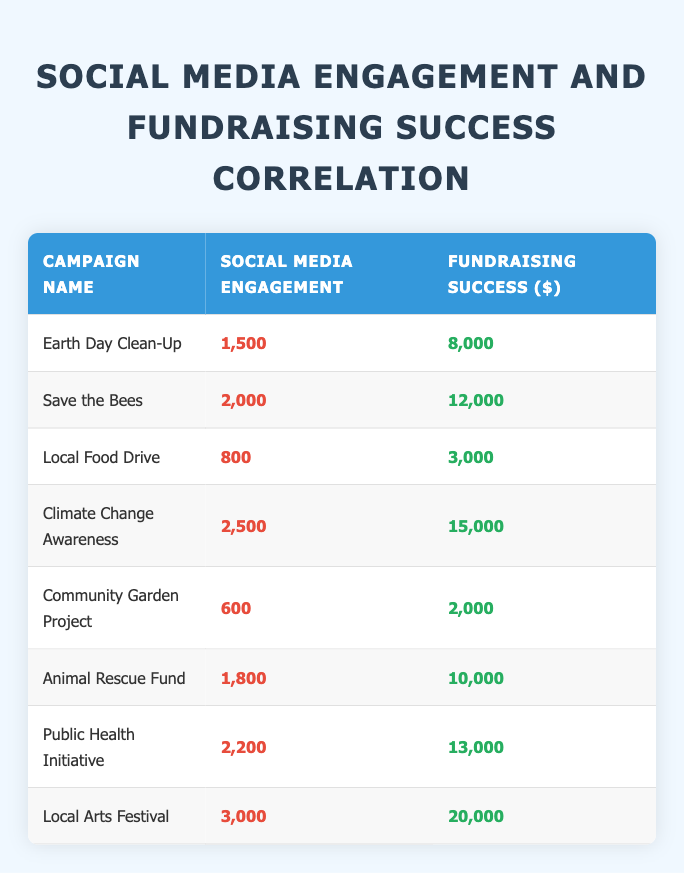What is the fundraising success for the "Save the Bees" campaign? According to the table, the fundraising success for the "Save the Bees" campaign is directly listed under the corresponding row, which shows a value of $12,000.
Answer: 12,000 Which campaign has the lowest social media engagement? By reviewing the social media engagement values in the column, "Community Garden Project" has the lowest engagement with 600.
Answer: Community Garden Project What is the difference in fundraising success between the "Local Arts Festival" and "Climate Change Awareness"? First, find the fundraising success amounts for each campaign: "Local Arts Festival" is $20,000, and "Climate Change Awareness" is $15,000. Then, calculate the difference: $20,000 - $15,000 = $5,000.
Answer: 5,000 Is the social media engagement for "Animal Rescue Fund" greater than 2,000? Looking at the engagement figure for "Animal Rescue Fund," which is 1,800, it is less than 2,000. Therefore the statement is false.
Answer: No What is the average fundraising success for all campaigns? To find the average, first sum up all the fundraising success values: 8,000 + 12,000 + 3,000 + 15,000 + 2,000 + 10,000 + 13,000 + 20,000 = 83,000. There are 8 campaigns, so divide by 8: 83,000 / 8 = 10,375.
Answer: 10,375 Which campaign had the highest social media engagement? By comparing the engagement numbers listed in the table, "Local Arts Festival" has the highest engagement with 3,000.
Answer: Local Arts Festival Are there any campaigns with both social media engagement and fundraising success lower than 1,000? Looking through the table, the campaigns "Community Garden Project" and "Local Food Drive" have fundraising successes lower than 3,000 and social media engagement lower than 1,800. Thus, the statement is true.
Answer: Yes What is the sum of social media engagements for the campaigns focusing on environmental issues, namely "Earth Day Clean-Up," "Save the Bees," and "Climate Change Awareness"? First, identify the engagements: "Earth Day Clean-Up" is 1,500, "Save the Bees" is 2,000, and "Climate Change Awareness" is 2,500. Calculate the total: 1,500 + 2,000 + 2,500 = 6,000.
Answer: 6,000 